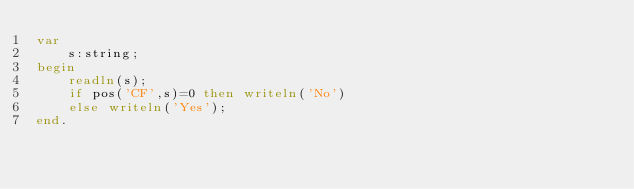Convert code to text. <code><loc_0><loc_0><loc_500><loc_500><_Pascal_>var
    s:string;
begin
    readln(s);
    if pos('CF',s)=0 then writeln('No')
    else writeln('Yes');
end.</code> 